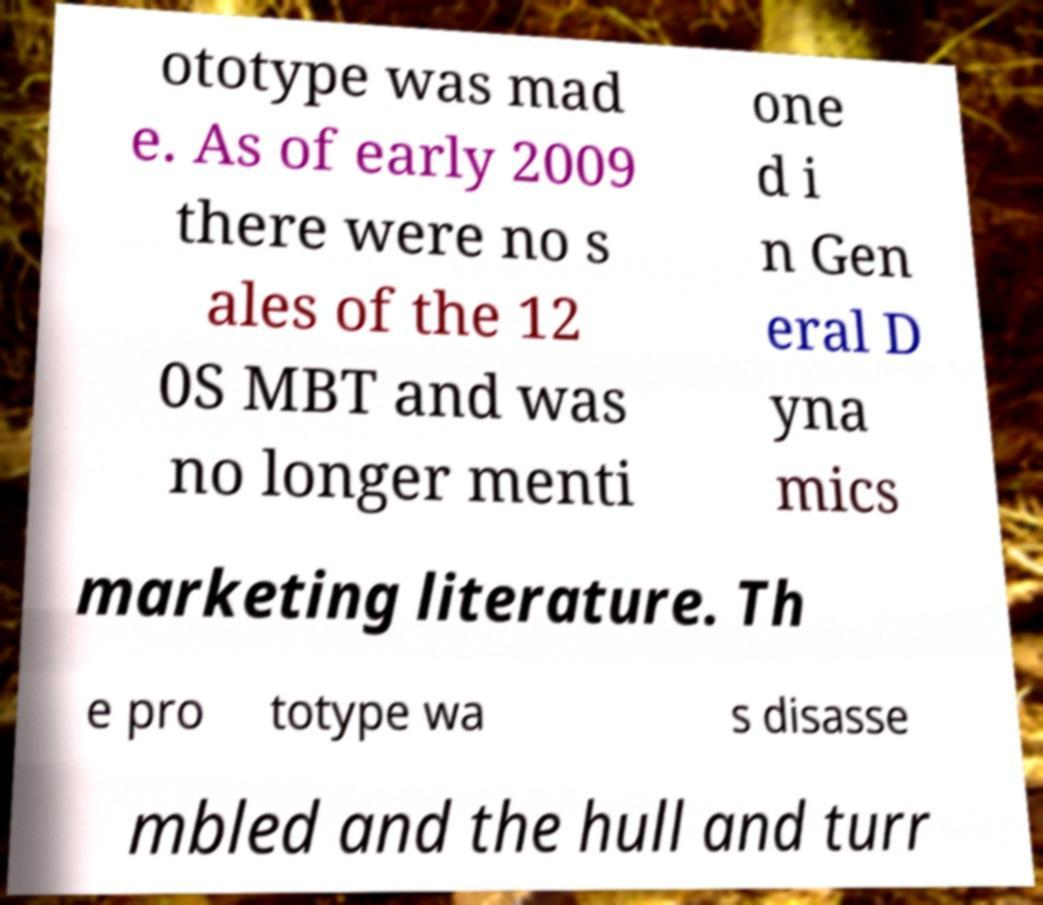Please read and relay the text visible in this image. What does it say? ototype was mad e. As of early 2009 there were no s ales of the 12 0S MBT and was no longer menti one d i n Gen eral D yna mics marketing literature. Th e pro totype wa s disasse mbled and the hull and turr 